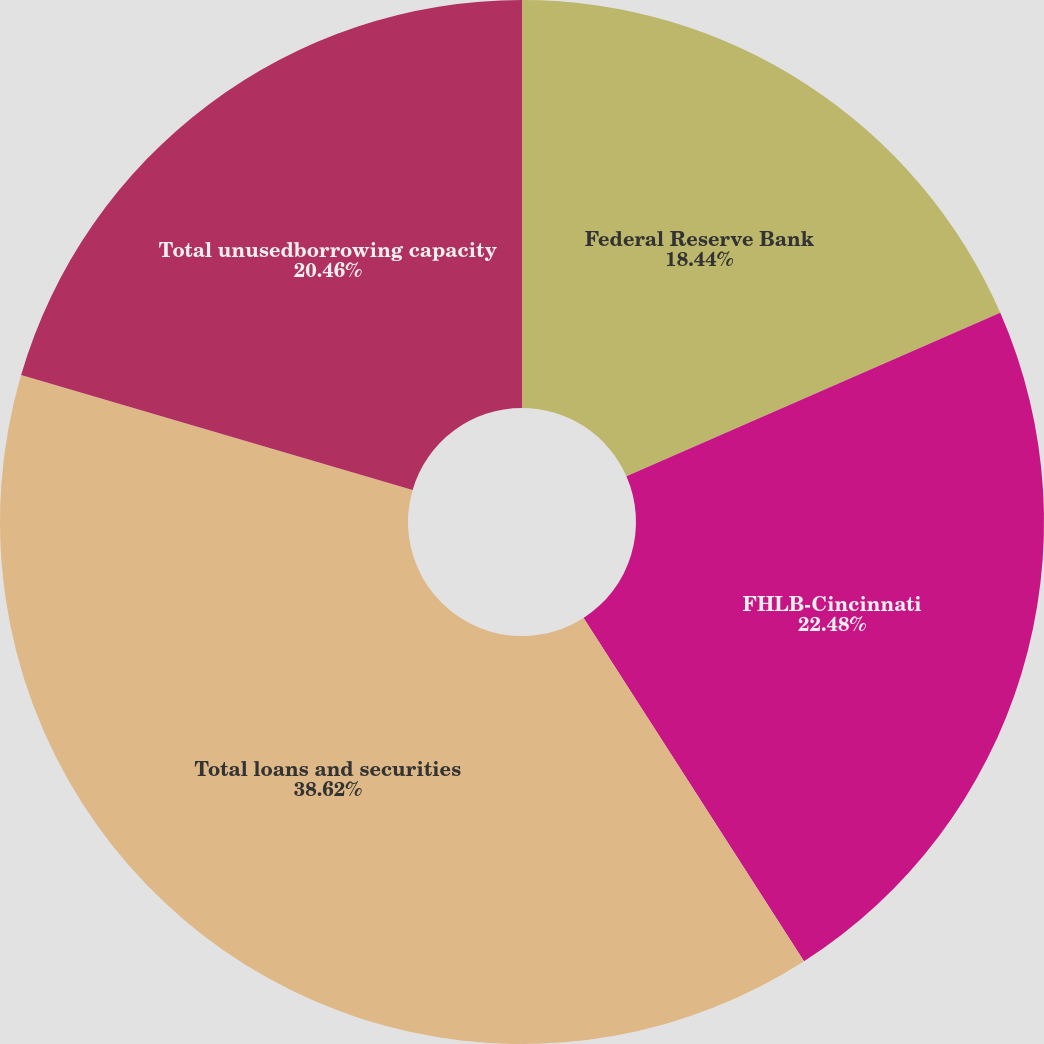<chart> <loc_0><loc_0><loc_500><loc_500><pie_chart><fcel>Federal Reserve Bank<fcel>FHLB-Cincinnati<fcel>Total loans and securities<fcel>Total unusedborrowing capacity<nl><fcel>18.44%<fcel>22.48%<fcel>38.63%<fcel>20.46%<nl></chart> 